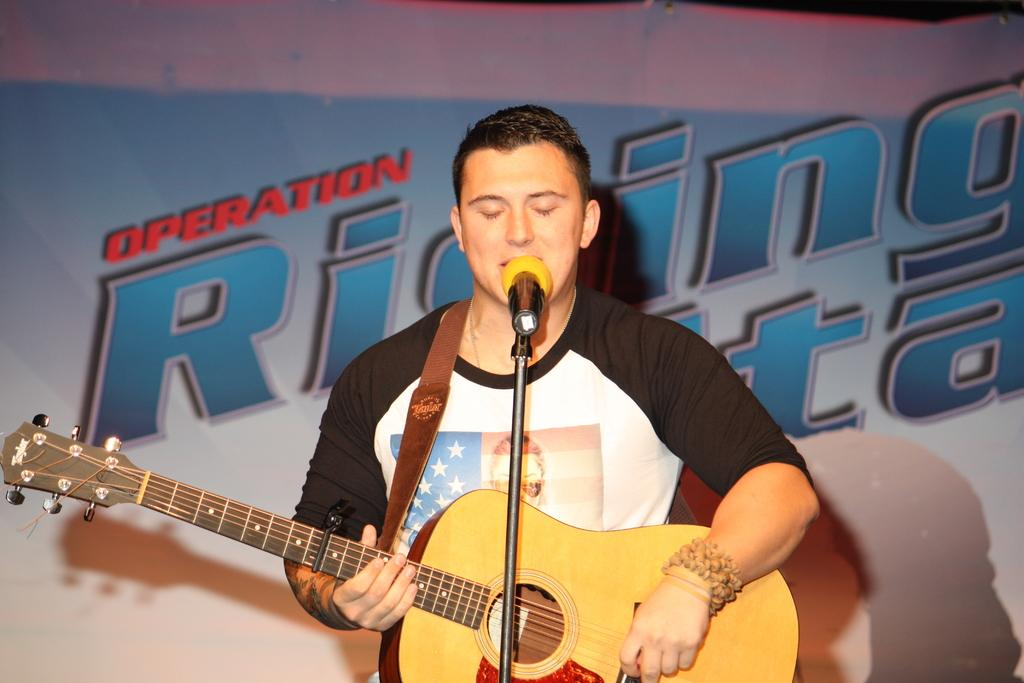What is the man in the image doing? The man is singing and playing a guitar. How is the man playing the guitar? The man is holding a guitar in his hands. What is the man using to amplify his voice? There is a microphone in the image. What is the man standing near in the image? There is a stand in the image. What can be seen in the background of the image? There is a poster in the background of the image. What type of wing does the man have in the image? There is no mention of wings in the image; the man is playing a guitar and singing. What does the man's dad think about his performance in the image? There is no information about the man's dad or his opinion in the image. 